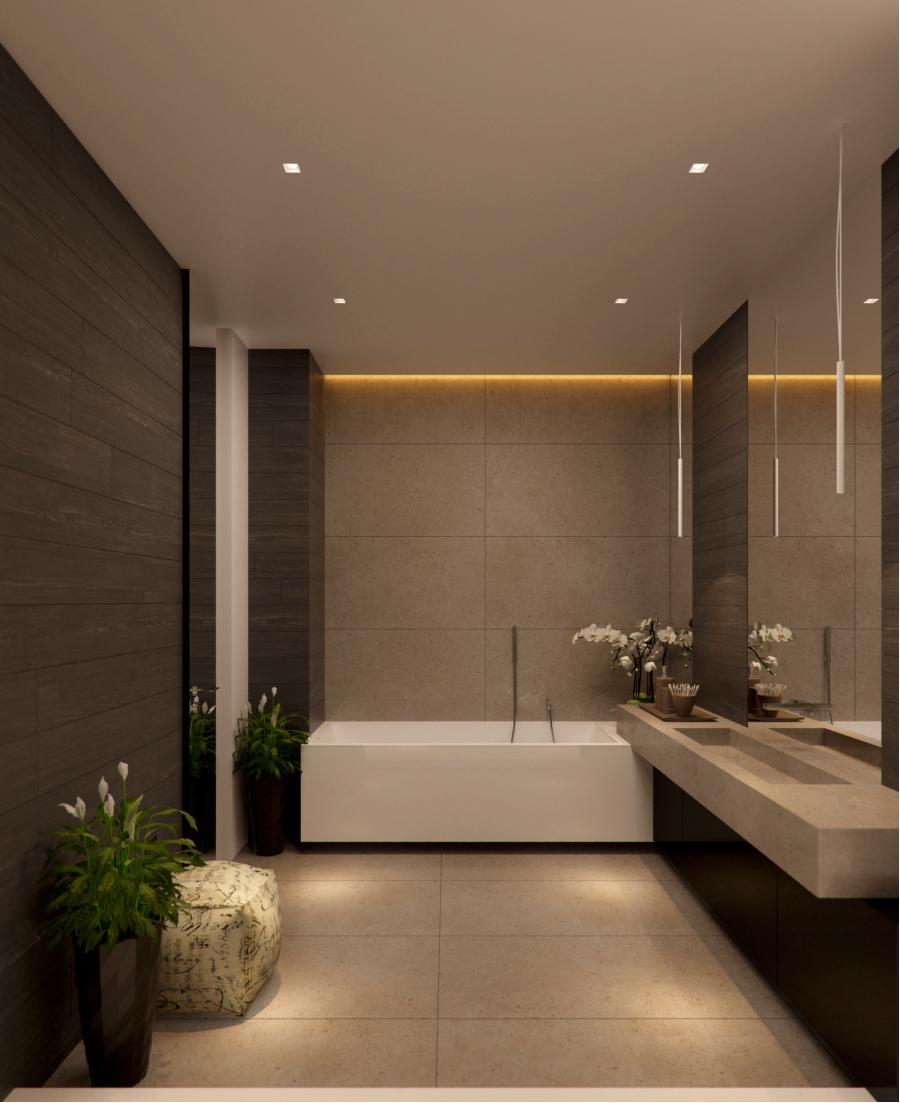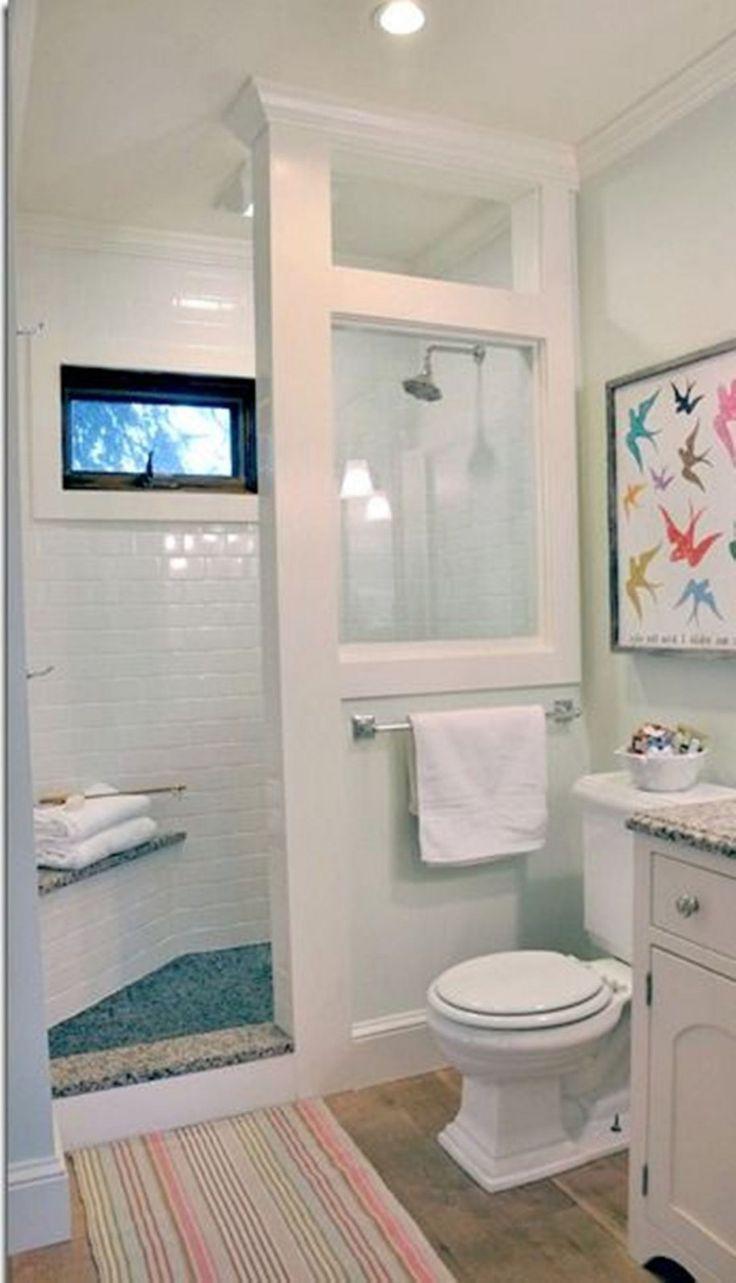The first image is the image on the left, the second image is the image on the right. Considering the images on both sides, is "In one image, a panel of the shower enclosure has a lower section that is an extension of the bathroom wall and an upper section that is a clear glass window showing the shower head." valid? Answer yes or no. Yes. The first image is the image on the left, the second image is the image on the right. For the images displayed, is the sentence "An image shows a paned window near a sink with one spout and separate faucet handles." factually correct? Answer yes or no. No. 